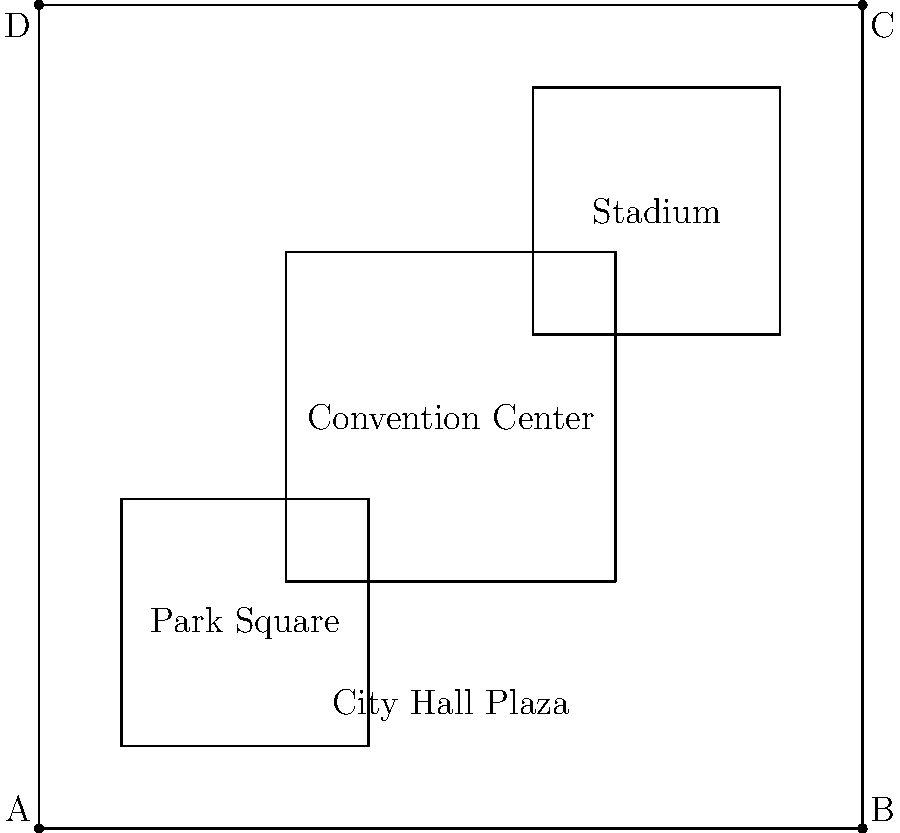As a campaign manager, you're planning rallies in different venues. The map shows four potential rally locations: City Hall Plaza, Convention Center, Park Square, and Stadium. If you need to accommodate the largest possible crowd, which venue should you choose based on the relative sizes shown on the map? To determine the largest venue, we need to compare the sizes of the rectangles representing each location on the map:

1. City Hall Plaza: Spans the entire width of the map but only about 1/3 of the height.
2. Convention Center: Occupies roughly the central 4/9 of the map area.
3. Park Square: Located in the top-left corner, occupying about 1/9 of the map area.
4. Stadium: Located in the bottom-right corner, occupying about 1/9 of the map area.

By visually comparing these areas:

- The Convention Center is clearly larger than both Park Square and the Stadium.
- City Hall Plaza, while spanning the entire width, is not as tall as the Convention Center.
- The Convention Center appears to be the largest overall area on the map.

Therefore, based on the relative sizes shown on the map, the Convention Center would accommodate the largest possible crowd for a rally.
Answer: Convention Center 